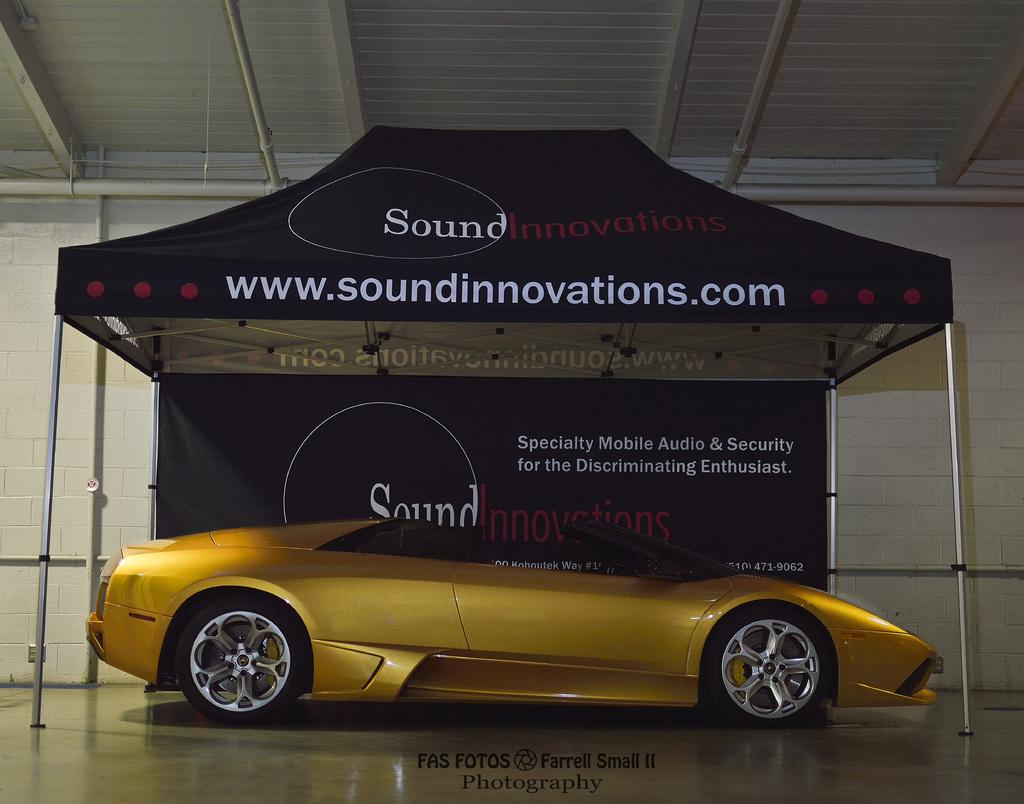What object is placed on the floor in the image? There is a car on the floor in the image. What additional item can be seen in the image? There is a banner in the image. What structure is visible in the image? There is a tent in the image. What can be seen in the background of the image? There is a wall visible in the background of the image. What type of horn can be heard coming from the car in the image? There is no indication of a horn or any sound in the image, as it only shows a car, a banner, a tent, and a wall in the background. 